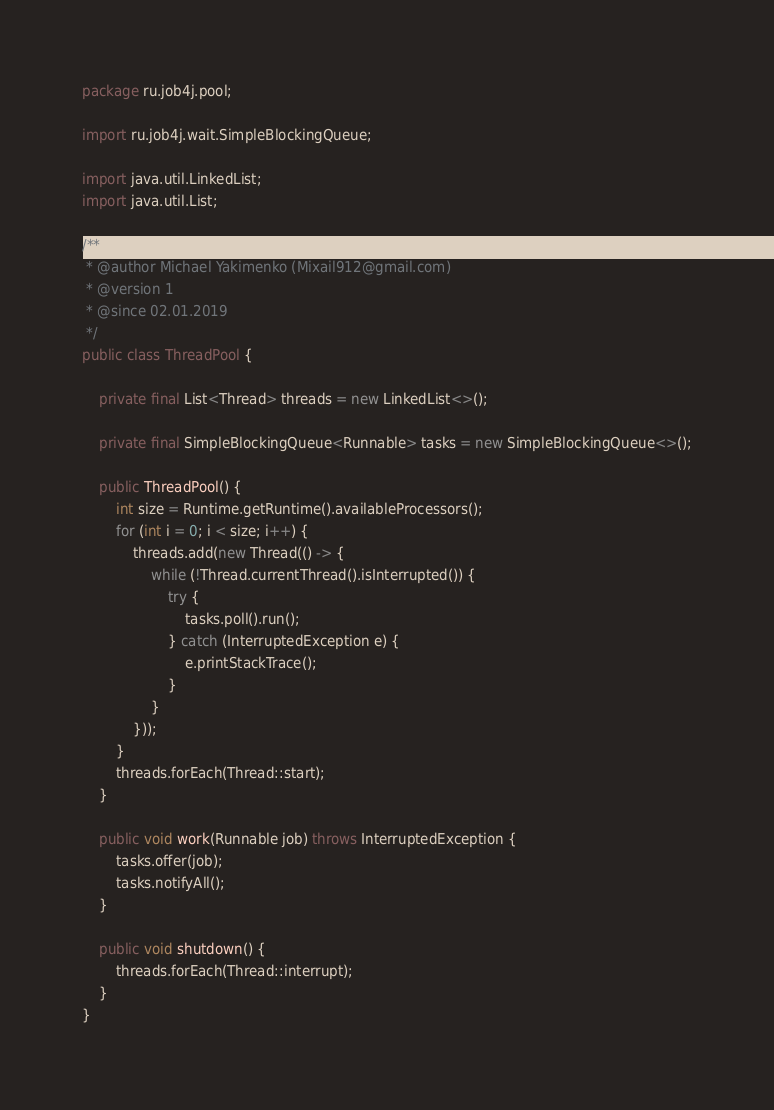<code> <loc_0><loc_0><loc_500><loc_500><_Java_>package ru.job4j.pool;

import ru.job4j.wait.SimpleBlockingQueue;

import java.util.LinkedList;
import java.util.List;

/**
 * @author Michael Yakimenko (Mixail912@gmail.com)
 * @version 1
 * @since 02.01.2019
 */
public class ThreadPool {

    private final List<Thread> threads = new LinkedList<>();

    private final SimpleBlockingQueue<Runnable> tasks = new SimpleBlockingQueue<>();

    public ThreadPool() {
        int size = Runtime.getRuntime().availableProcessors();
        for (int i = 0; i < size; i++) {
            threads.add(new Thread(() -> {
                while (!Thread.currentThread().isInterrupted()) {
                    try {
                        tasks.poll().run();
                    } catch (InterruptedException e) {
                        e.printStackTrace();
                    }
                }
            }));
        }
        threads.forEach(Thread::start);
    }

    public void work(Runnable job) throws InterruptedException {
        tasks.offer(job);
        tasks.notifyAll();
    }

    public void shutdown() {
        threads.forEach(Thread::interrupt);
    }
}
</code> 